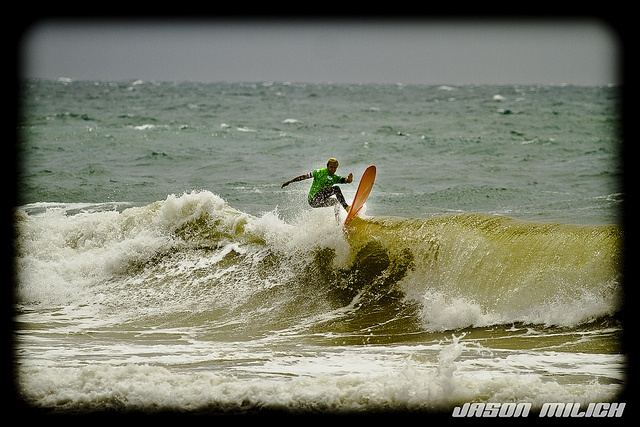Describe the objects in this image and their specific colors. I can see people in black, darkgray, darkgreen, and lightgray tones and surfboard in black, brown, maroon, and tan tones in this image. 